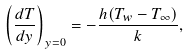Convert formula to latex. <formula><loc_0><loc_0><loc_500><loc_500>\left ( \frac { d T } { d y } \right ) _ { y = 0 } = - \frac { h ( T _ { w } - T _ { \infty } ) } { k } ,</formula> 